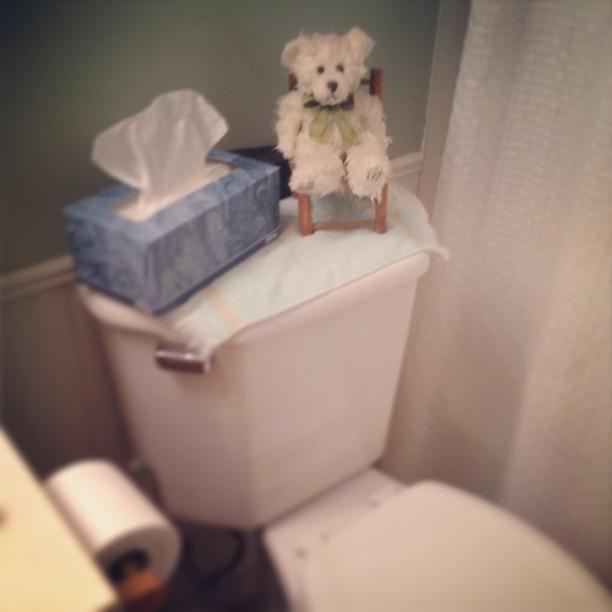What animal is in the picture?
Give a very brief answer. Bear. What brand of tissues is that?
Give a very brief answer. Kleenex. What is inside the box?
Give a very brief answer. Tissue. 